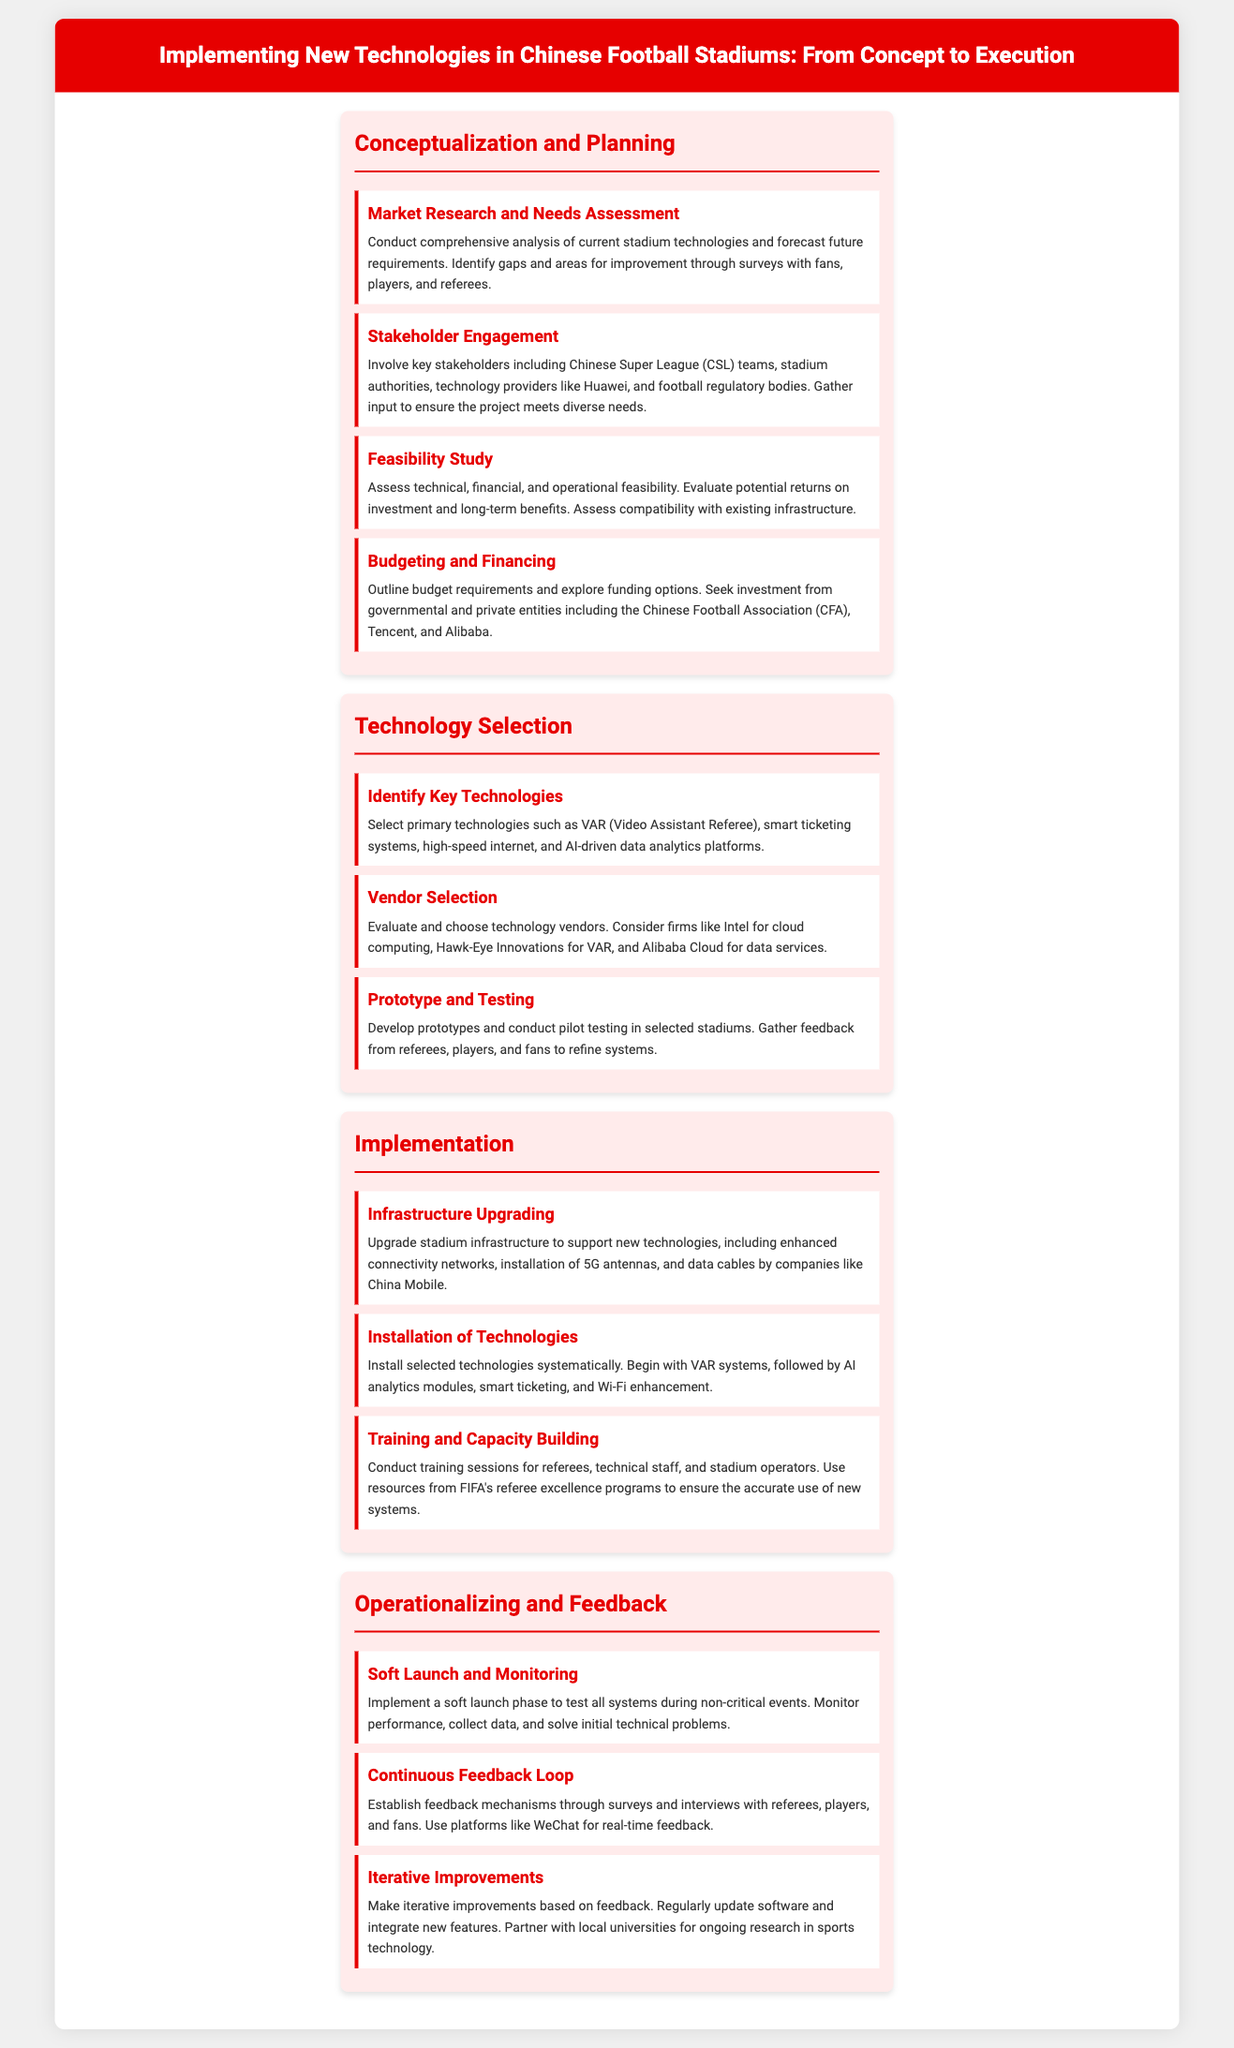what is the title of the document? The title of the document is prominently displayed at the top of the infographic, summarizing the main topic.
Answer: Implementing New Technologies in Chinese Football Stadiums: From Concept to Execution who are the key stakeholders involved in the planning phase? The stakeholders include various entities involved in the development of the project. They are mentioned in the section discussing stakeholder engagement.
Answer: Chinese Super League teams, stadium authorities, technology providers, and football regulatory bodies name one technology selected for implementation. The document lists various technologies to be implemented, specifically mentioned in the technology selection section.
Answer: VAR (Video Assistant Referee) which company is mentioned for cloud computing services? The document identifies specific companies in the vendor selection step for technology provision.
Answer: Intel what is one purpose of the soft launch phase? The soft launch phase's purpose is outlined in the operationalizing and feedback section, detailing the initial implementation steps.
Answer: To test all systems during non-critical events how is feedback collected after the technologies are implemented? The document describes mechanisms for obtaining feedback from various participants, specifically in the continuous feedback loop section.
Answer: Through surveys and interviews with referees, players, and fans which company is mentioned for enhancing data cables and connectivity? The document specifies companies involved in infrastructure upgrading, mentioned in the implementation section.
Answer: China Mobile what is the focus of the iterative improvements step? This step is elaborated in the operationalizing and feedback section, summarizing ongoing development efforts.
Answer: Based on feedback 